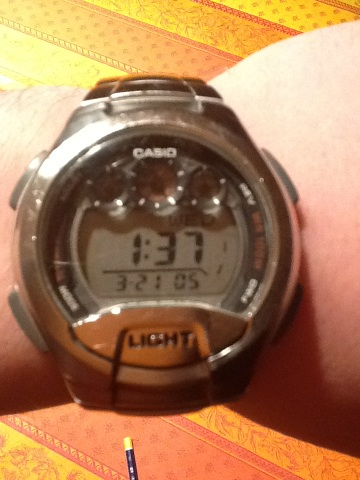Is there anything special about the design of this watch? The watch design is quite utilitarian with a focus on function over form. It's a classic Casio design that prioritizes readability and durability. The digital display is large relative to the watch face, which makes it easy to read the time quickly. 